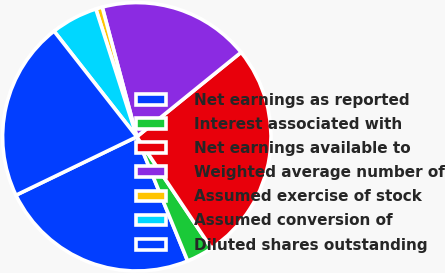<chart> <loc_0><loc_0><loc_500><loc_500><pie_chart><fcel>Net earnings as reported<fcel>Interest associated with<fcel>Net earnings available to<fcel>Weighted average number of<fcel>Assumed exercise of stock<fcel>Assumed conversion of<fcel>Diluted shares outstanding<nl><fcel>24.02%<fcel>3.21%<fcel>26.44%<fcel>18.31%<fcel>0.79%<fcel>5.64%<fcel>21.59%<nl></chart> 